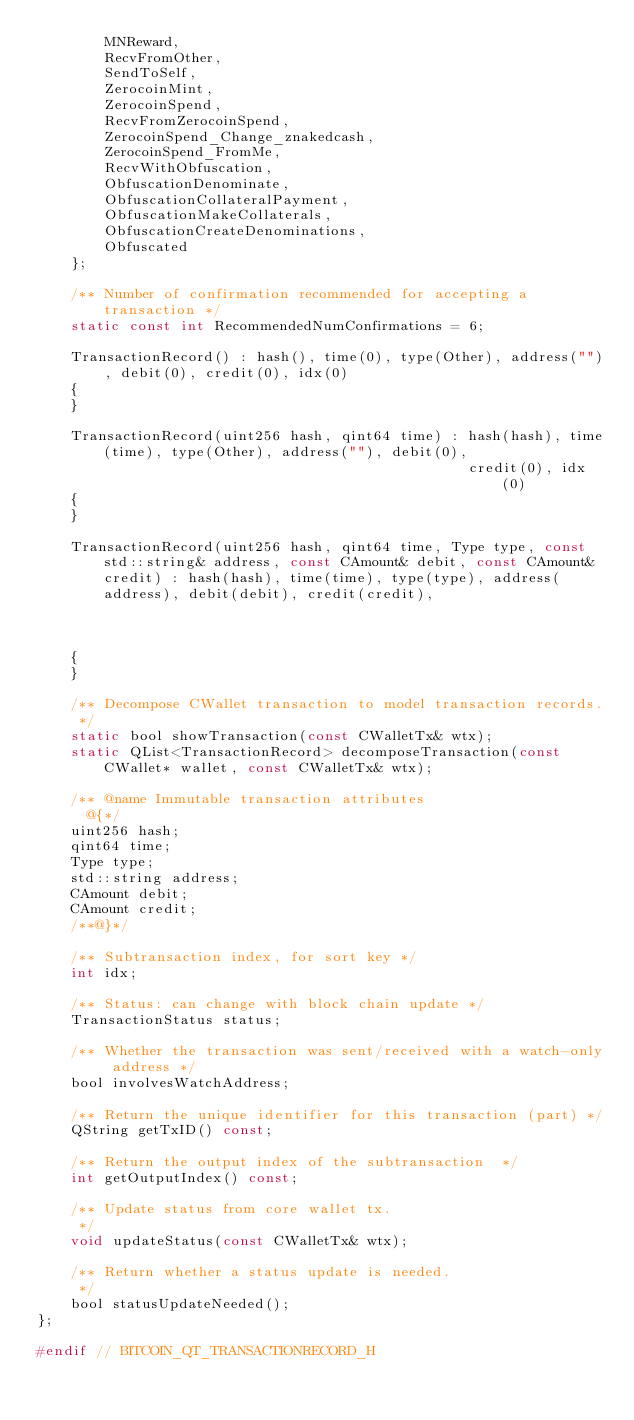Convert code to text. <code><loc_0><loc_0><loc_500><loc_500><_C_>        MNReward,
        RecvFromOther,
        SendToSelf,
        ZerocoinMint,
        ZerocoinSpend,
        RecvFromZerocoinSpend,
        ZerocoinSpend_Change_znakedcash,
        ZerocoinSpend_FromMe,
        RecvWithObfuscation,
        ObfuscationDenominate,
        ObfuscationCollateralPayment,
        ObfuscationMakeCollaterals,
        ObfuscationCreateDenominations,
        Obfuscated
    };

    /** Number of confirmation recommended for accepting a transaction */
    static const int RecommendedNumConfirmations = 6;

    TransactionRecord() : hash(), time(0), type(Other), address(""), debit(0), credit(0), idx(0)
    {
    }

    TransactionRecord(uint256 hash, qint64 time) : hash(hash), time(time), type(Other), address(""), debit(0),
                                                   credit(0), idx(0)
    {
    }

    TransactionRecord(uint256 hash, qint64 time, Type type, const std::string& address, const CAmount& debit, const CAmount& credit) : hash(hash), time(time), type(type), address(address), debit(debit), credit(credit),
                                                                                                                                       idx(0)
    {
    }

    /** Decompose CWallet transaction to model transaction records.
     */
    static bool showTransaction(const CWalletTx& wtx);
    static QList<TransactionRecord> decomposeTransaction(const CWallet* wallet, const CWalletTx& wtx);

    /** @name Immutable transaction attributes
      @{*/
    uint256 hash;
    qint64 time;
    Type type;
    std::string address;
    CAmount debit;
    CAmount credit;
    /**@}*/

    /** Subtransaction index, for sort key */
    int idx;

    /** Status: can change with block chain update */
    TransactionStatus status;

    /** Whether the transaction was sent/received with a watch-only address */
    bool involvesWatchAddress;

    /** Return the unique identifier for this transaction (part) */
    QString getTxID() const;

    /** Return the output index of the subtransaction  */
    int getOutputIndex() const;

    /** Update status from core wallet tx.
     */
    void updateStatus(const CWalletTx& wtx);

    /** Return whether a status update is needed.
     */
    bool statusUpdateNeeded();
};

#endif // BITCOIN_QT_TRANSACTIONRECORD_H
</code> 